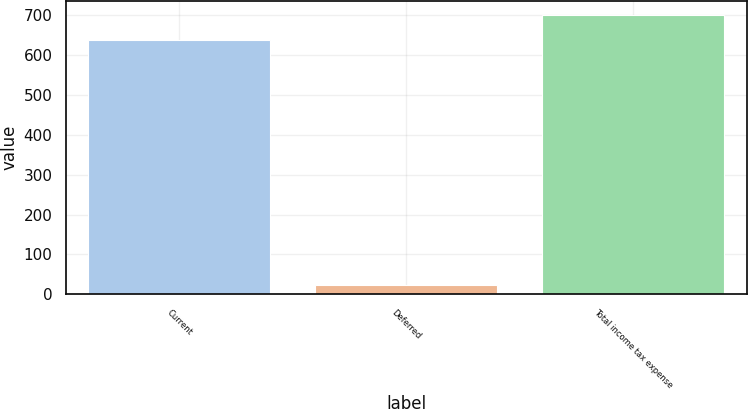Convert chart to OTSL. <chart><loc_0><loc_0><loc_500><loc_500><bar_chart><fcel>Current<fcel>Deferred<fcel>Total income tax expense<nl><fcel>636<fcel>24<fcel>699.6<nl></chart> 